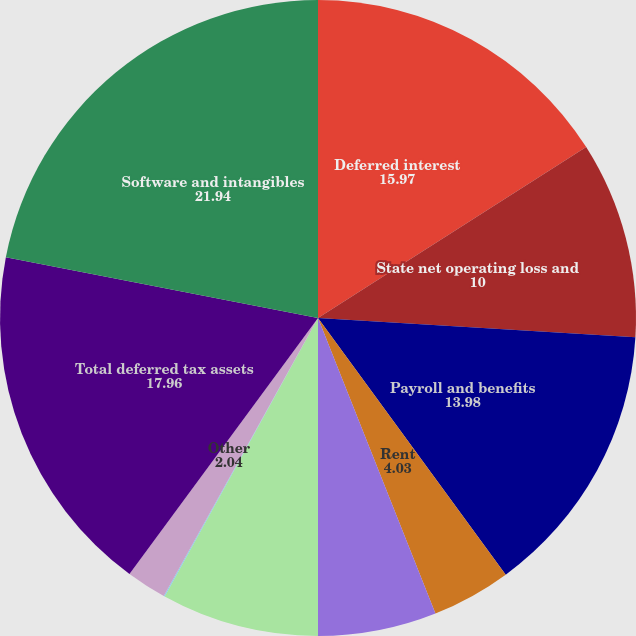Convert chart. <chart><loc_0><loc_0><loc_500><loc_500><pie_chart><fcel>Deferred interest<fcel>State net operating loss and<fcel>Payroll and benefits<fcel>Rent<fcel>Accounts receivable<fcel>Equity compensation plans<fcel>Trade credits<fcel>Other<fcel>Total deferred tax assets<fcel>Software and intangibles<nl><fcel>15.97%<fcel>10.0%<fcel>13.98%<fcel>4.03%<fcel>6.02%<fcel>8.01%<fcel>0.05%<fcel>2.04%<fcel>17.96%<fcel>21.94%<nl></chart> 